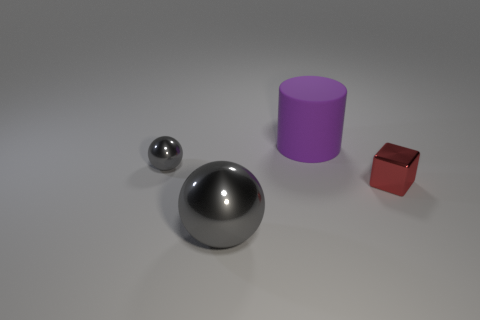Are there any other things that have the same material as the large purple cylinder?
Offer a very short reply. No. What material is the gray object that is the same size as the cube?
Your answer should be very brief. Metal. Is there a red metallic object in front of the tiny metallic object in front of the gray ball that is behind the shiny cube?
Give a very brief answer. No. Is there any other thing that has the same shape as the big gray metallic thing?
Your answer should be very brief. Yes. There is a block on the right side of the purple thing; is its color the same as the object that is in front of the small red block?
Your response must be concise. No. Are there any big gray objects?
Make the answer very short. Yes. There is a big sphere that is the same color as the small shiny ball; what is it made of?
Provide a succinct answer. Metal. What size is the shiny ball that is in front of the shiny sphere that is behind the gray shiny sphere that is in front of the red metal block?
Provide a succinct answer. Large. There is a large gray thing; is its shape the same as the large thing that is behind the tiny gray shiny sphere?
Offer a very short reply. No. Is there a sphere of the same color as the big metal thing?
Your answer should be compact. Yes. 